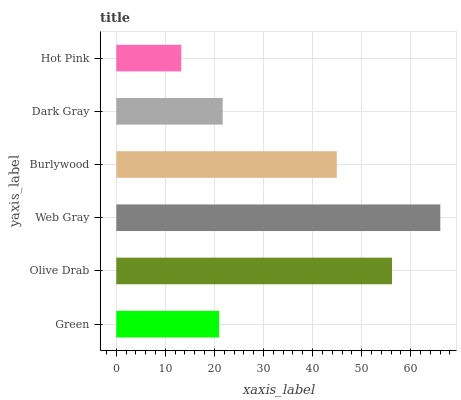Is Hot Pink the minimum?
Answer yes or no. Yes. Is Web Gray the maximum?
Answer yes or no. Yes. Is Olive Drab the minimum?
Answer yes or no. No. Is Olive Drab the maximum?
Answer yes or no. No. Is Olive Drab greater than Green?
Answer yes or no. Yes. Is Green less than Olive Drab?
Answer yes or no. Yes. Is Green greater than Olive Drab?
Answer yes or no. No. Is Olive Drab less than Green?
Answer yes or no. No. Is Burlywood the high median?
Answer yes or no. Yes. Is Dark Gray the low median?
Answer yes or no. Yes. Is Olive Drab the high median?
Answer yes or no. No. Is Burlywood the low median?
Answer yes or no. No. 